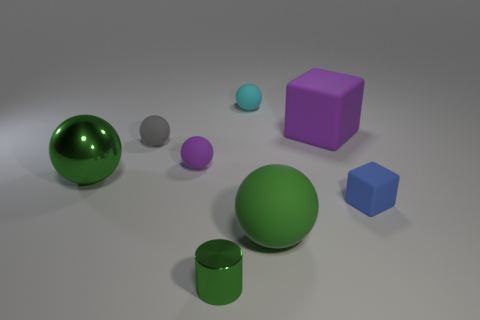Are there fewer small shiny cylinders to the left of the gray rubber thing than large rubber objects behind the large metallic object?
Make the answer very short. Yes. Is the color of the large metallic sphere the same as the shiny cylinder?
Give a very brief answer. Yes. Are there fewer small purple spheres left of the blue rubber thing than things?
Your answer should be very brief. Yes. There is a ball that is the same color as the big matte cube; what is its material?
Your response must be concise. Rubber. Is the large purple cube made of the same material as the tiny purple thing?
Make the answer very short. Yes. How many cyan objects are made of the same material as the tiny gray thing?
Provide a short and direct response. 1. What is the color of the other block that is the same material as the tiny block?
Your answer should be very brief. Purple. What is the shape of the tiny cyan object?
Your answer should be compact. Sphere. There is a cube that is left of the tiny blue matte object; what is its material?
Ensure brevity in your answer.  Rubber. Are there any tiny shiny things of the same color as the shiny sphere?
Make the answer very short. Yes. 